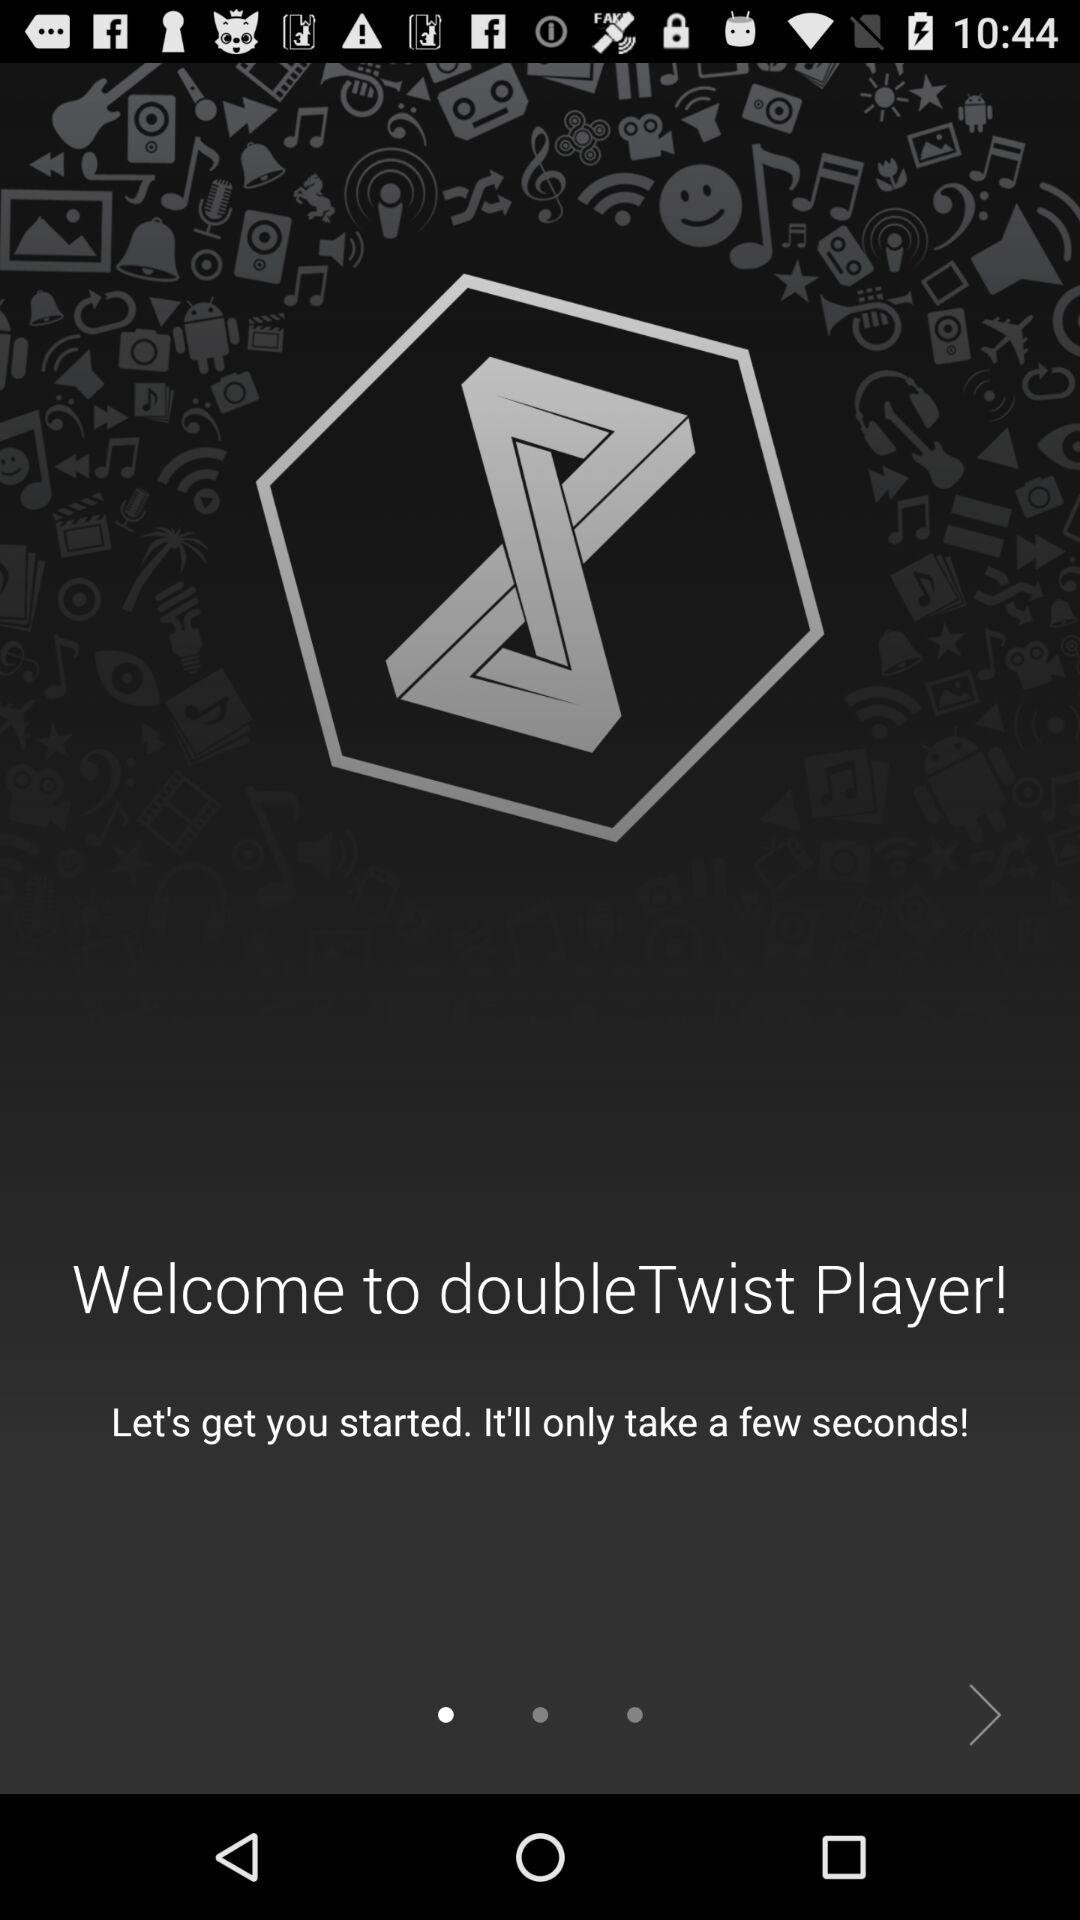What is the name of the application? The name of the application is "doubleTwist Player". 